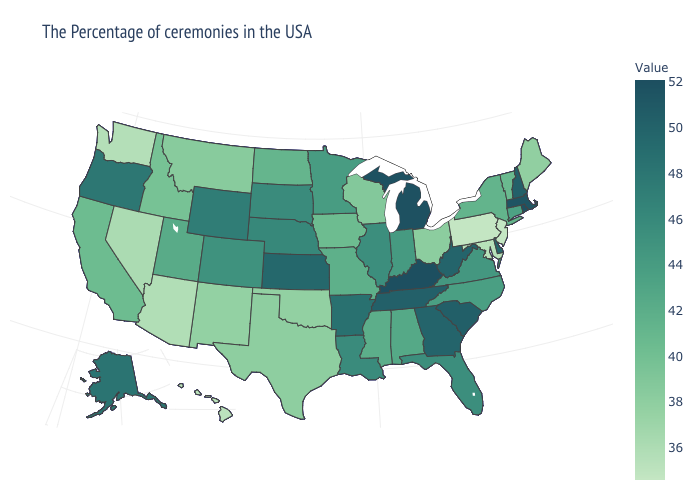Does Montana have a lower value than Oregon?
Be succinct. Yes. Among the states that border South Carolina , which have the lowest value?
Concise answer only. North Carolina. Among the states that border California , does Nevada have the highest value?
Be succinct. No. Does the map have missing data?
Write a very short answer. No. Does Arkansas have the highest value in the South?
Concise answer only. No. Among the states that border Idaho , which have the lowest value?
Concise answer only. Washington. 